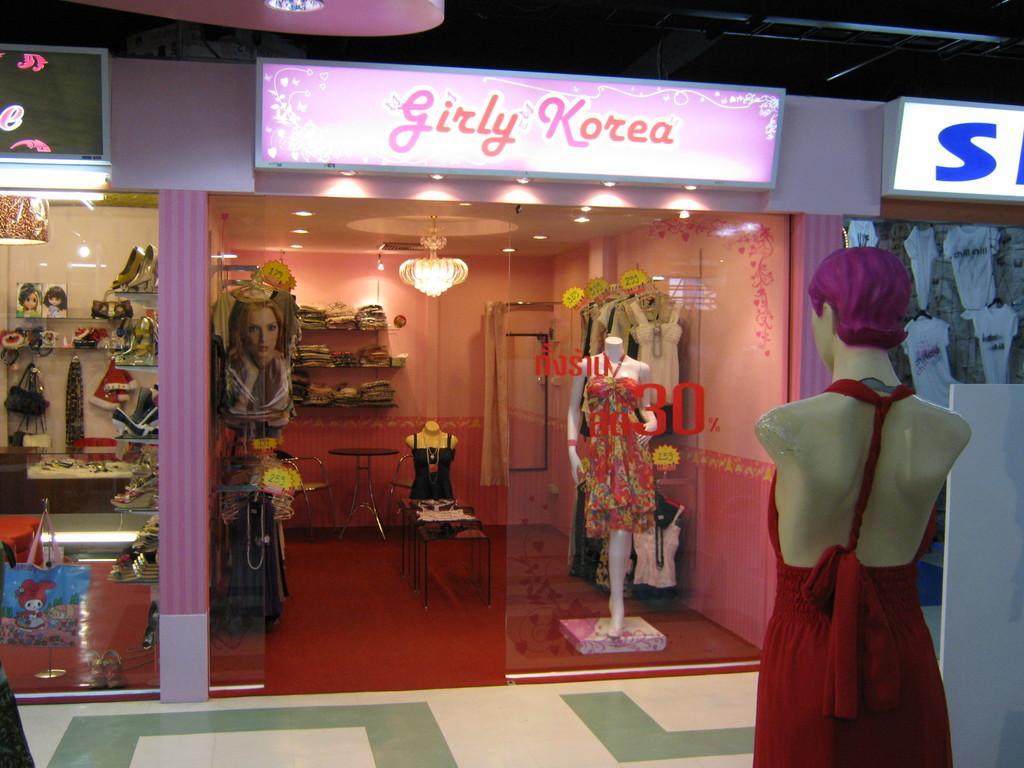Can you describe this image briefly? In this image I can see the mannequin and the dress which is in red color. In-front of the mannequin I can see the shop. Inside the shop I can see another mannequin with the dress. I can also see many colorful clothes. To the left there is an another stall with many things in it. I can see some boards on the top of the shop. 